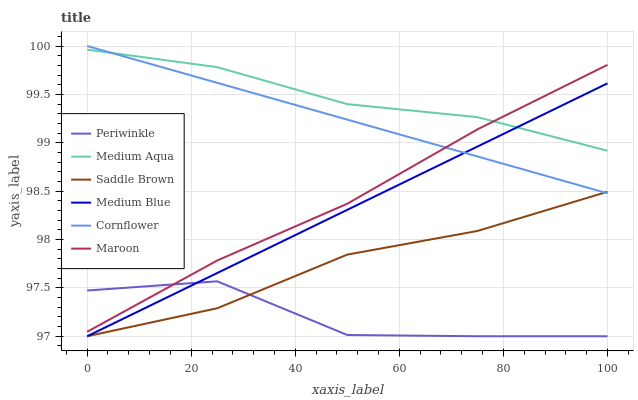Does Periwinkle have the minimum area under the curve?
Answer yes or no. Yes. Does Medium Aqua have the maximum area under the curve?
Answer yes or no. Yes. Does Medium Blue have the minimum area under the curve?
Answer yes or no. No. Does Medium Blue have the maximum area under the curve?
Answer yes or no. No. Is Cornflower the smoothest?
Answer yes or no. Yes. Is Periwinkle the roughest?
Answer yes or no. Yes. Is Maroon the smoothest?
Answer yes or no. No. Is Maroon the roughest?
Answer yes or no. No. Does Maroon have the lowest value?
Answer yes or no. No. Does Cornflower have the highest value?
Answer yes or no. Yes. Does Medium Blue have the highest value?
Answer yes or no. No. Is Periwinkle less than Medium Aqua?
Answer yes or no. Yes. Is Maroon greater than Saddle Brown?
Answer yes or no. Yes. Does Periwinkle intersect Saddle Brown?
Answer yes or no. Yes. Is Periwinkle less than Saddle Brown?
Answer yes or no. No. Is Periwinkle greater than Saddle Brown?
Answer yes or no. No. Does Periwinkle intersect Medium Aqua?
Answer yes or no. No. 